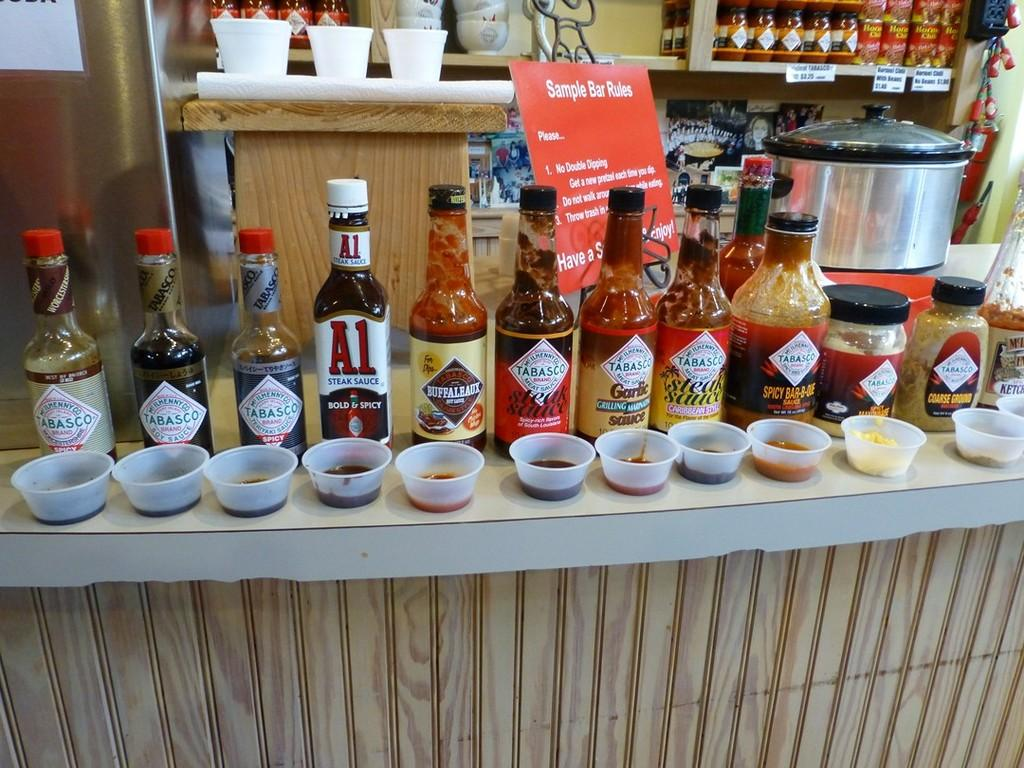<image>
Write a terse but informative summary of the picture. Several kinds of sauces including A1 and Tabasco are lined up in front of sample cups. 